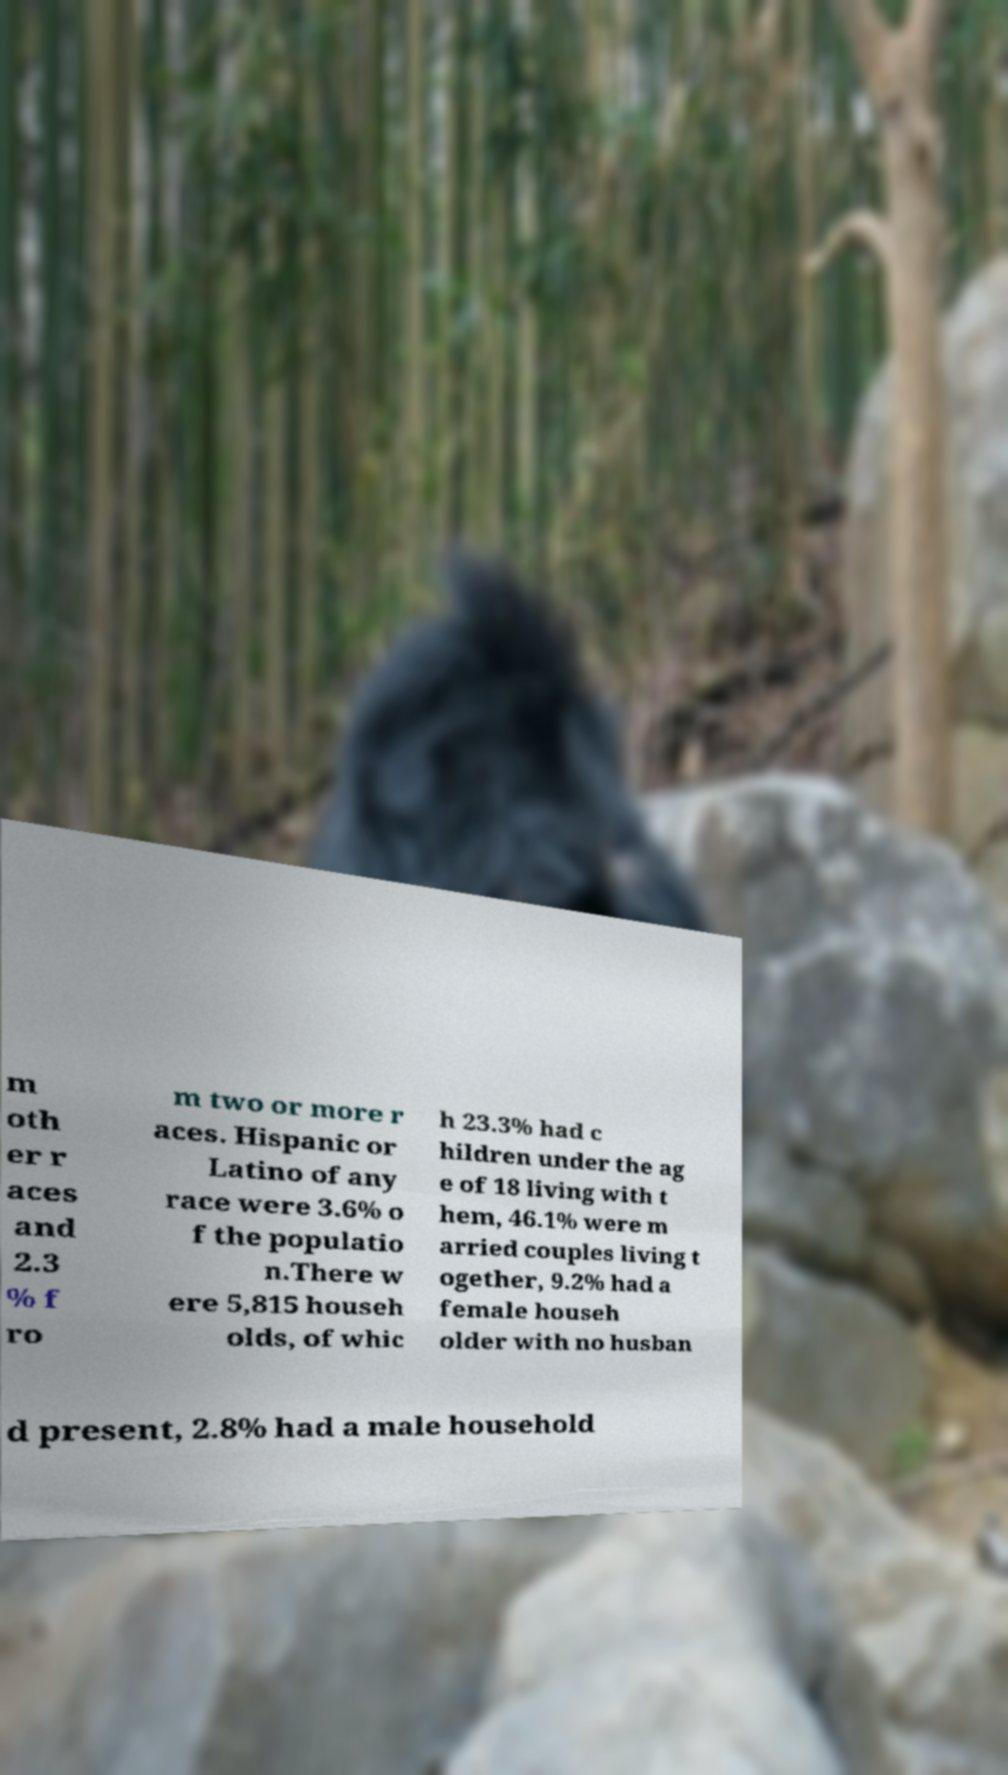What messages or text are displayed in this image? I need them in a readable, typed format. m oth er r aces and 2.3 % f ro m two or more r aces. Hispanic or Latino of any race were 3.6% o f the populatio n.There w ere 5,815 househ olds, of whic h 23.3% had c hildren under the ag e of 18 living with t hem, 46.1% were m arried couples living t ogether, 9.2% had a female househ older with no husban d present, 2.8% had a male household 